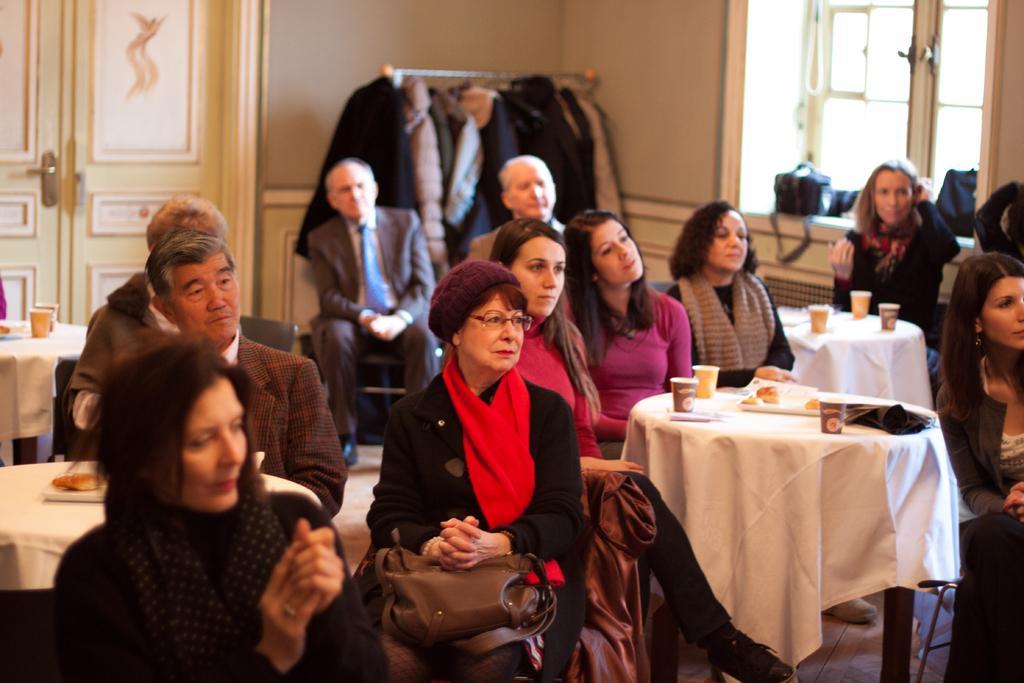In one or two sentences, can you explain what this image depicts? This picture is of inside the room. In the foreground there are group of persons sitting on the chairs and there are tables on the top of which glasses, food items are placed. In the background there is a window and a table on the top of which bags are placed and there is a stand and the clothes are hanging on the stand and we can see the door. 